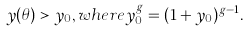Convert formula to latex. <formula><loc_0><loc_0><loc_500><loc_500>y ( \theta ) > y _ { 0 } , w h e r e y _ { 0 } ^ { g } = ( 1 + y _ { 0 } ) ^ { g - 1 } .</formula> 